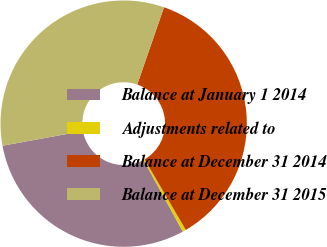Convert chart to OTSL. <chart><loc_0><loc_0><loc_500><loc_500><pie_chart><fcel>Balance at January 1 2014<fcel>Adjustments related to<fcel>Balance at December 31 2014<fcel>Balance at December 31 2015<nl><fcel>30.1%<fcel>0.45%<fcel>36.26%<fcel>33.18%<nl></chart> 